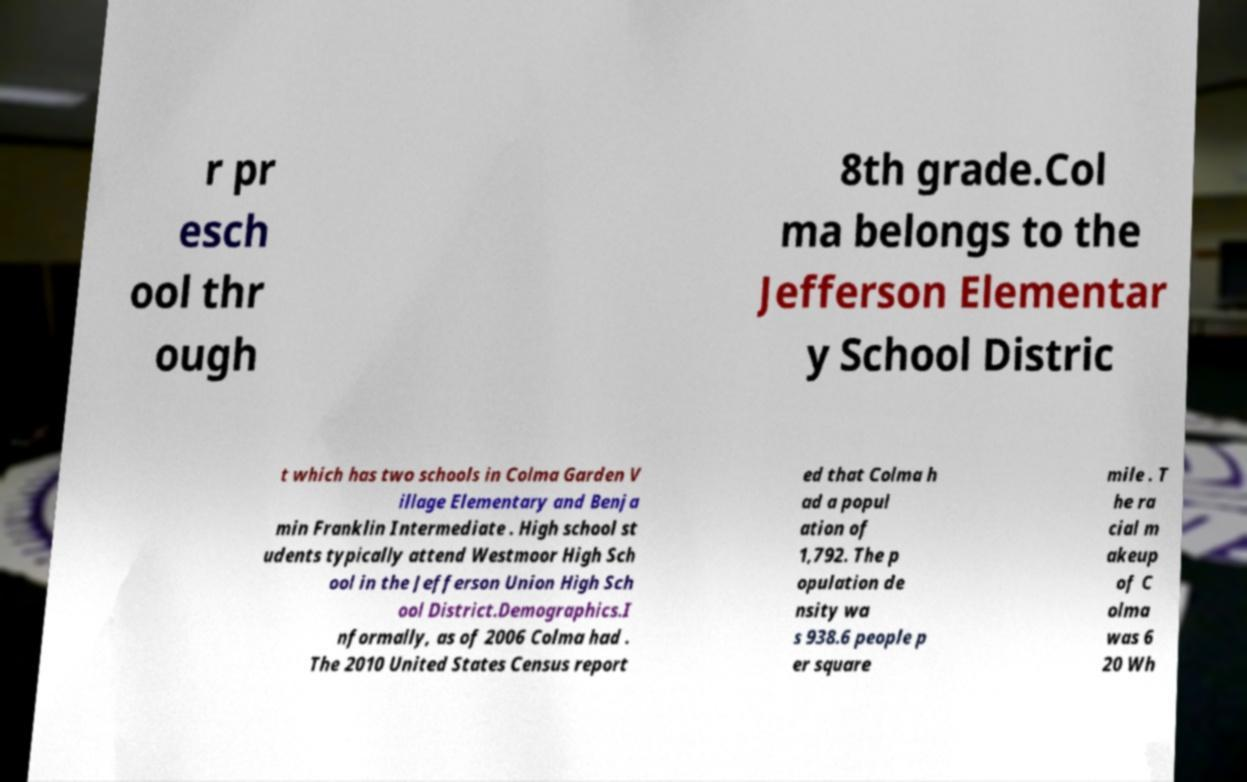Please identify and transcribe the text found in this image. r pr esch ool thr ough 8th grade.Col ma belongs to the Jefferson Elementar y School Distric t which has two schools in Colma Garden V illage Elementary and Benja min Franklin Intermediate . High school st udents typically attend Westmoor High Sch ool in the Jefferson Union High Sch ool District.Demographics.I nformally, as of 2006 Colma had . The 2010 United States Census report ed that Colma h ad a popul ation of 1,792. The p opulation de nsity wa s 938.6 people p er square mile . T he ra cial m akeup of C olma was 6 20 Wh 